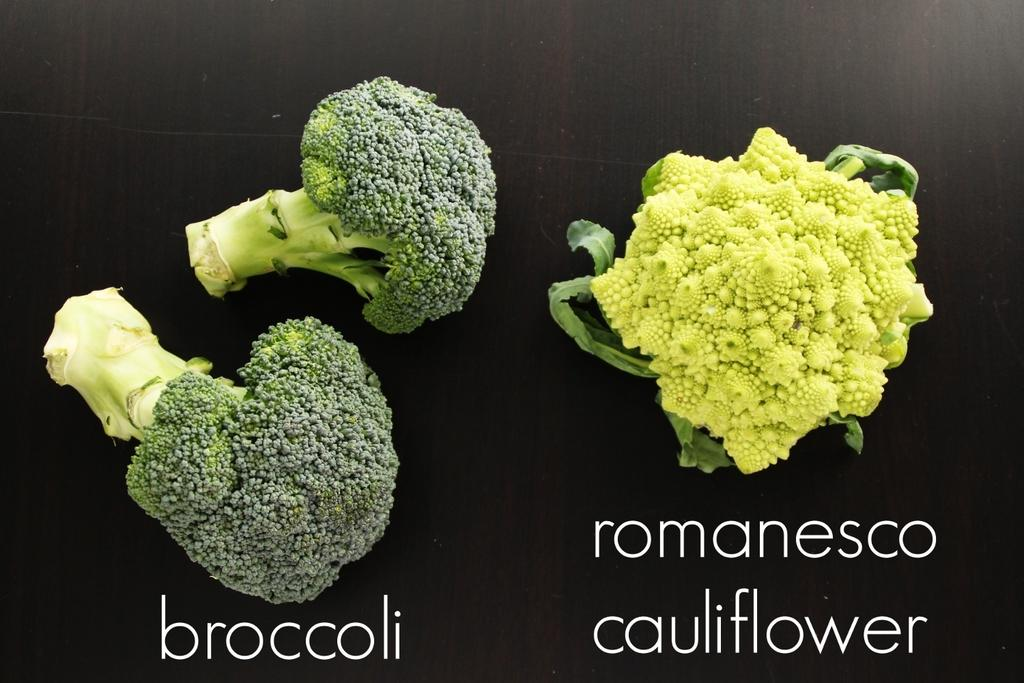What vegetables can be seen on the surface in the image? There is broccoli and cauliflower on the surface in the image. How are the names of these vegetables displayed on the surface? The names of these vegetables are present on the surface. What type of wood can be seen in the image? There is no wood present in the image; it features broccoli and cauliflower on a surface with their names displayed. 